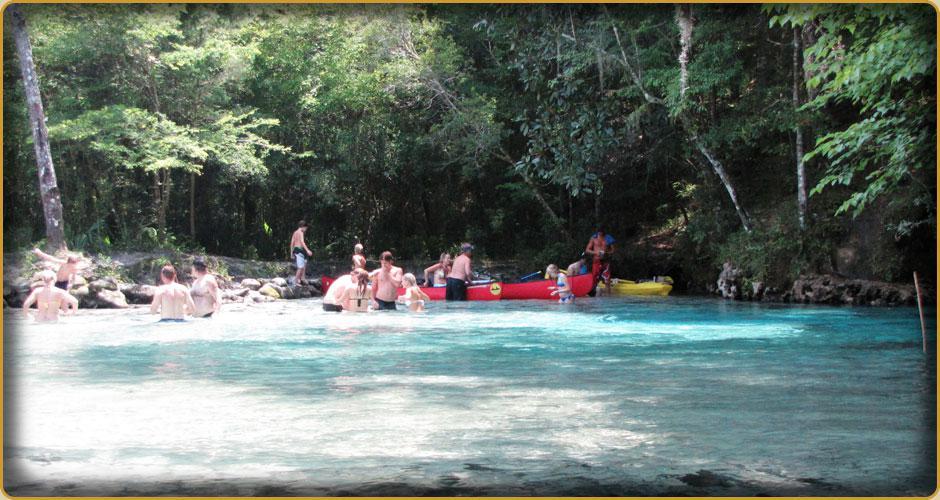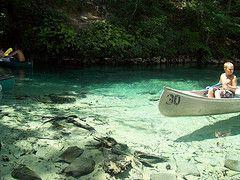The first image is the image on the left, the second image is the image on the right. For the images shown, is this caption "There is a woman in the image on the right." true? Answer yes or no. No. 